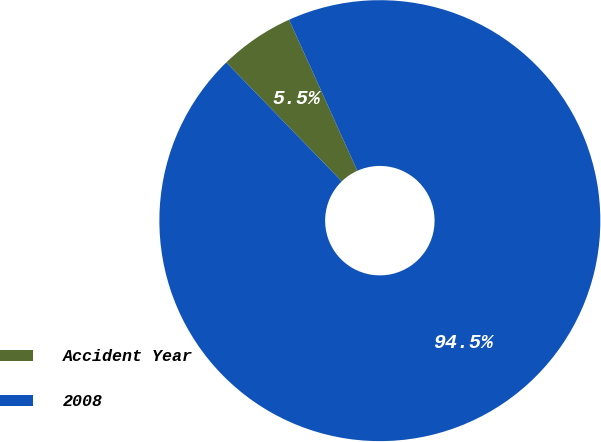Convert chart. <chart><loc_0><loc_0><loc_500><loc_500><pie_chart><fcel>Accident Year<fcel>2008<nl><fcel>5.51%<fcel>94.49%<nl></chart> 